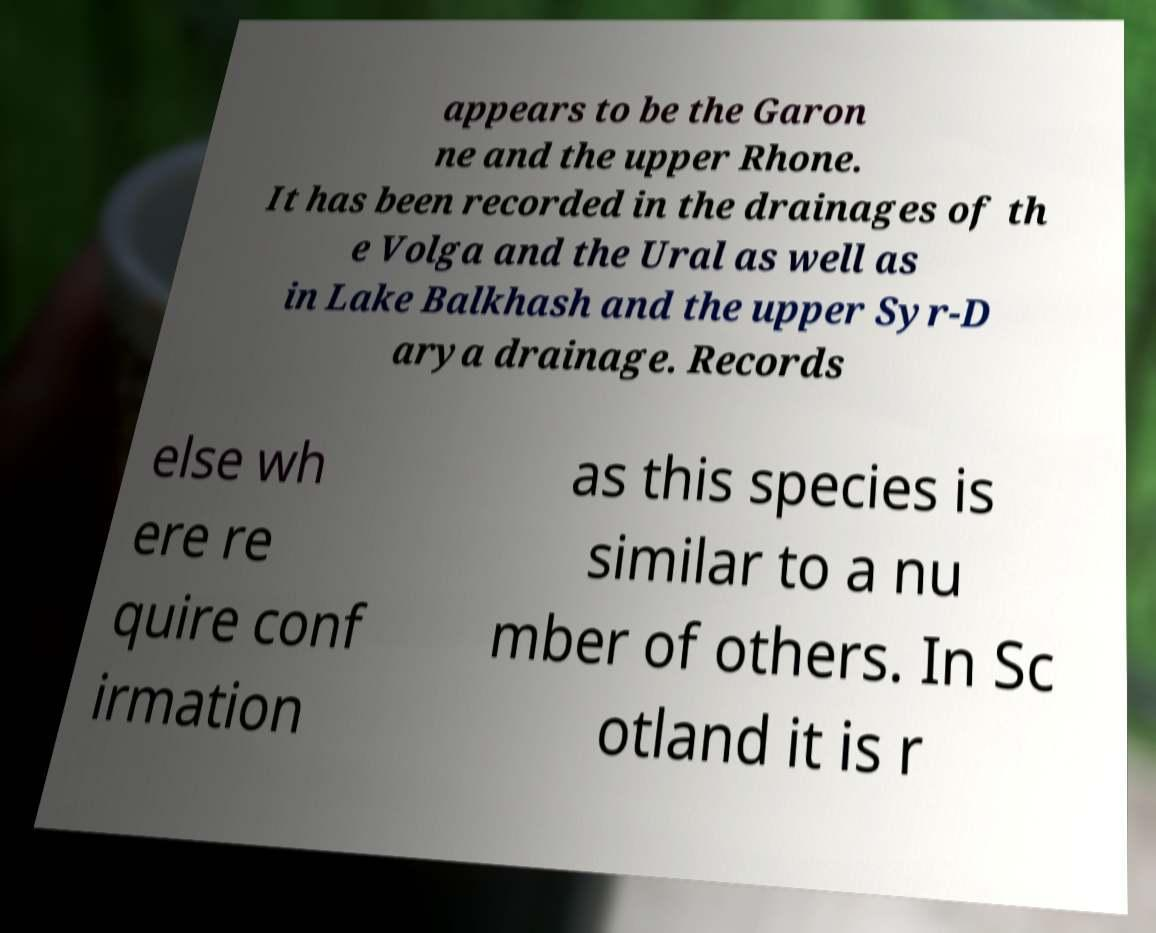What messages or text are displayed in this image? I need them in a readable, typed format. appears to be the Garon ne and the upper Rhone. It has been recorded in the drainages of th e Volga and the Ural as well as in Lake Balkhash and the upper Syr-D arya drainage. Records else wh ere re quire conf irmation as this species is similar to a nu mber of others. In Sc otland it is r 